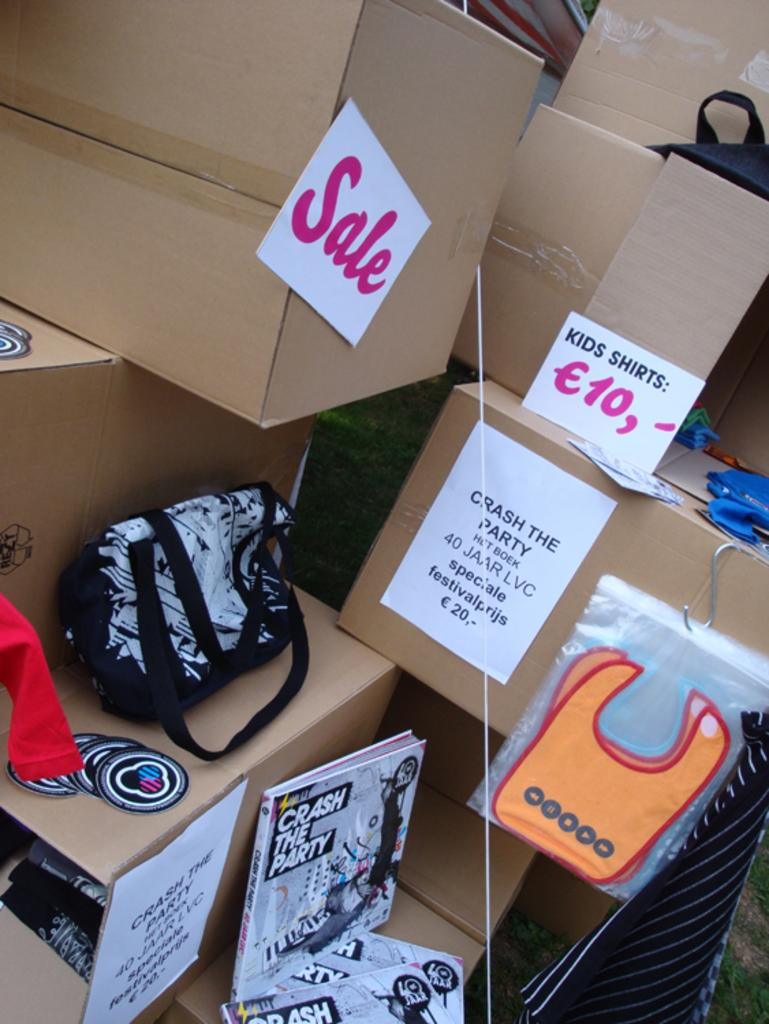<image>
Present a compact description of the photo's key features. Bunch of boxes with a Sales box right next to a Kids Shirt box. 